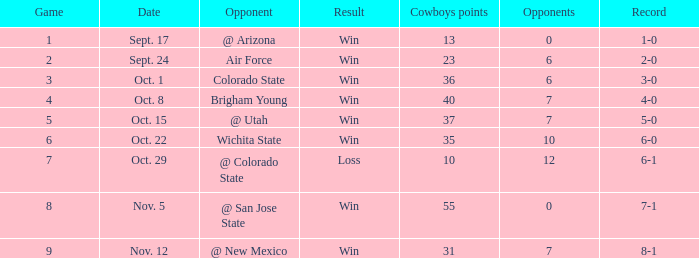What was the Cowboys' record for Nov. 5, 1966? 7-1. 